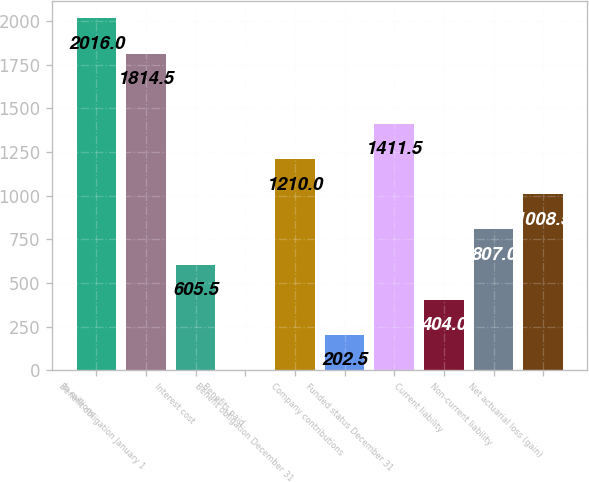Convert chart. <chart><loc_0><loc_0><loc_500><loc_500><bar_chart><fcel>In millions<fcel>Benefit obligation January 1<fcel>Interest cost<fcel>Benefits paid<fcel>Benefit obligation December 31<fcel>Company contributions<fcel>Funded status December 31<fcel>Current liability<fcel>Non-current liability<fcel>Net actuarial loss (gain)<nl><fcel>2016<fcel>1814.5<fcel>605.5<fcel>1<fcel>1210<fcel>202.5<fcel>1411.5<fcel>404<fcel>807<fcel>1008.5<nl></chart> 